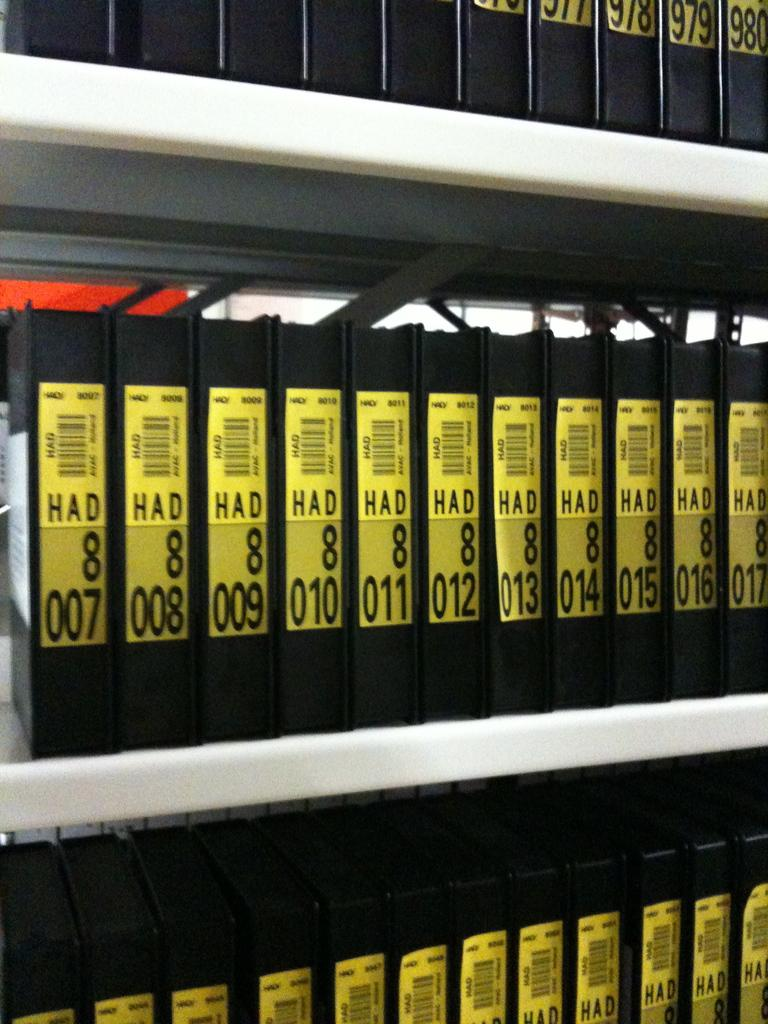Provide a one-sentence caption for the provided image. Shelves lined with books numbered in consecutive order. 